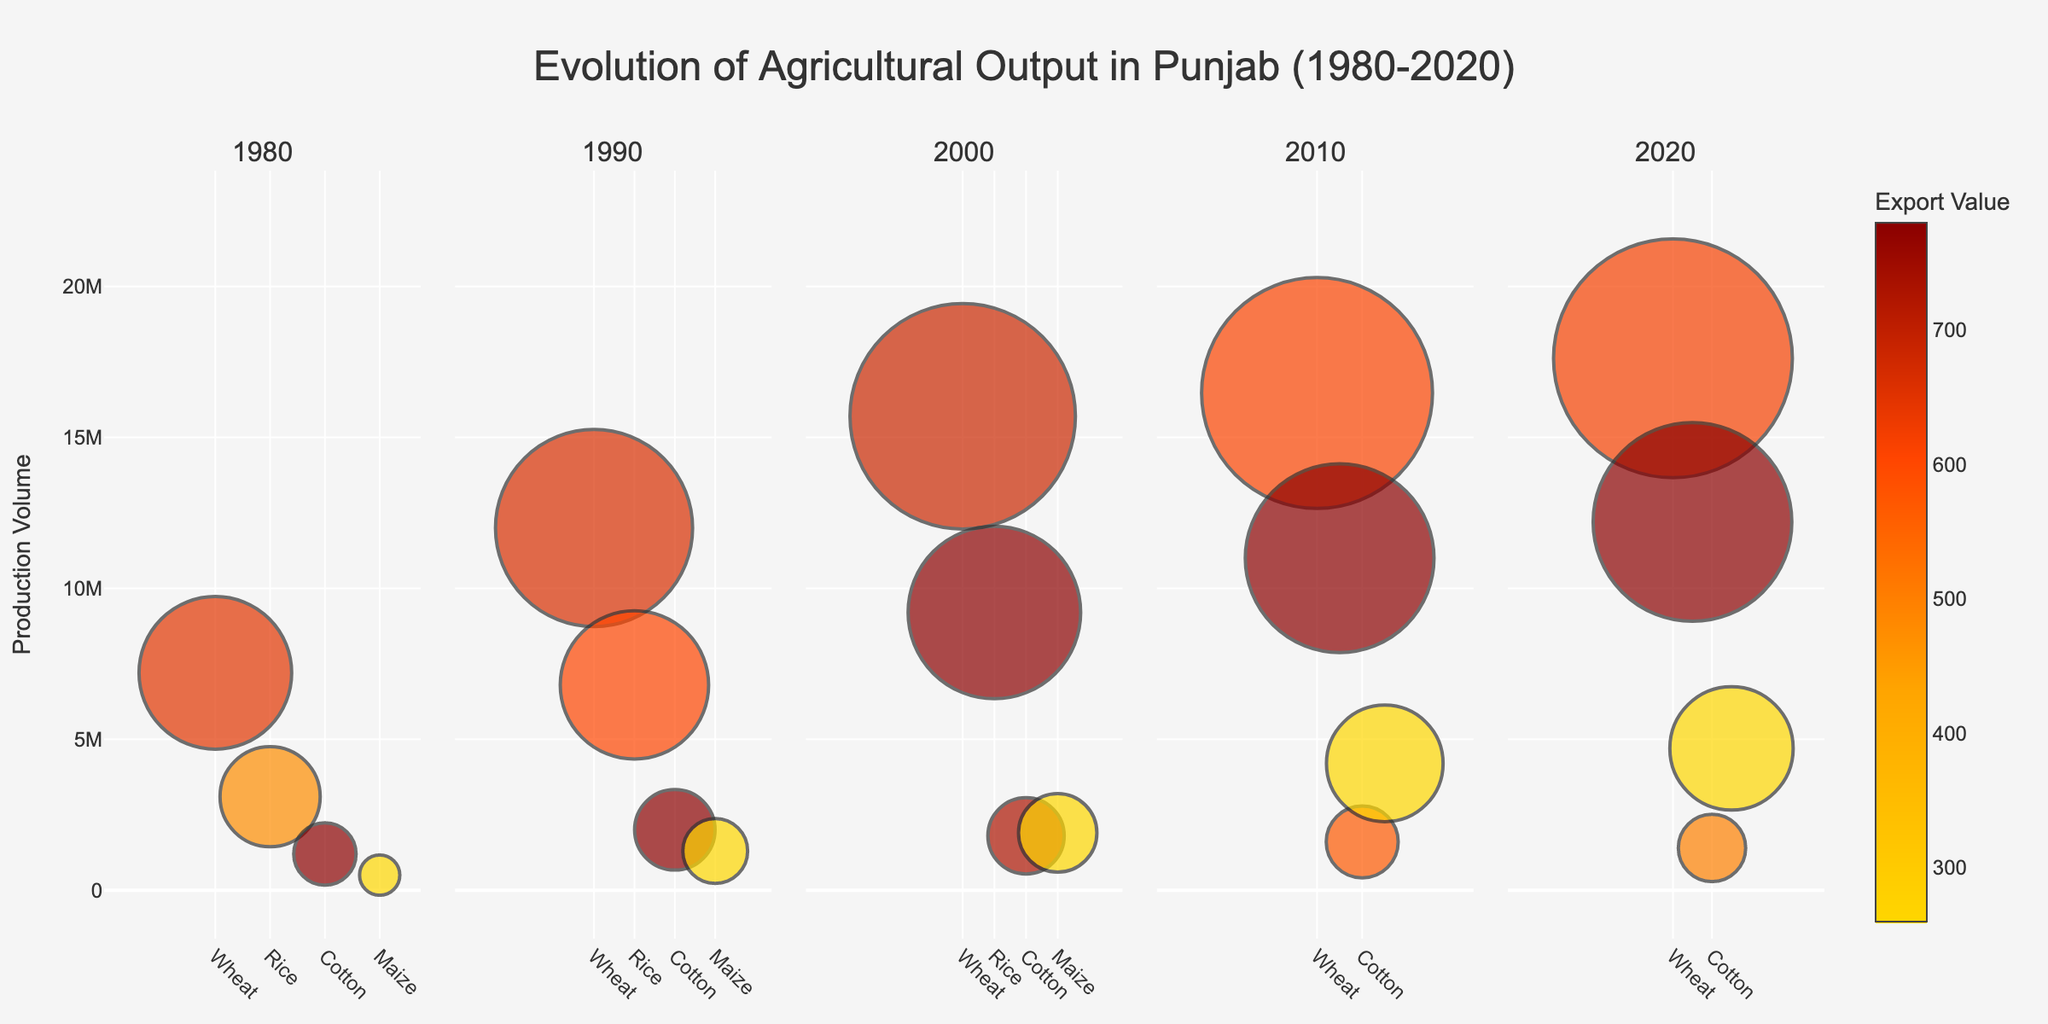What is the title of the figure? The title of the figure is prominently displayed at the top. It reads "Evolution of Agricultural Output in Punjab (1980-2020)."
Answer: Evolution of Agricultural Output in Punjab (1980-2020) Which crop had the highest export value in 2020? In the 2020 subplot, the crop with the darkest colored bubble has the highest export value. This crop is Rice.
Answer: Rice How did the production volume of Wheat change from 1980 to 2020? By comparing the relative sizes of the bubbles representing Wheat in the 1980 and 2020 subplots, it is clear that the bubble size increased significantly.
Answer: Increased Which year had the highest overall export values for crops? By observing the color intensity in each subplot, the 2020 subplot has the most dark-colored bubbles, indicating the highest export values.
Answer: 2020 Compare the production volume of Maize between 1990 and 2010. The Maize bubble in 2010 is larger than the one in 1990 when comparing their sizes directly.
Answer: Larger in 2010 What is the general trend in the export value of Cotton from 1980 to 2020? By examining the color gradient associated with Cotton bubbles in each year, there's a trend of increasing darkness, showing an upward trend in export value.
Answer: Increasing Which crop showed the greatest increase in production volume from 1980 to 2020? By comparing the size of bubbles, Maize exhibited the most significant increase in bubble size, indicating the greatest rise in production volume.
Answer: Maize How does the diversity in the color of bubbles vary across the subplots? Comparing the color variation across the subplots, 2020 shows the greatest diversity in shades, reflecting a greater range of export values.
Answer: Greatest in 2020 What was the production volume of Rice in 1990? The size of the bubble for Rice in the 1990 subplot indicates the production volume, which is shown as 6,800,000.
Answer: 6,800,000 Which crop in 2010 had the smallest production volume, and how do you determine this from the figure? In the 2010 subplot, the smallest bubble represents Cotton, indicating it had the smallest production volume.
Answer: Cotton 